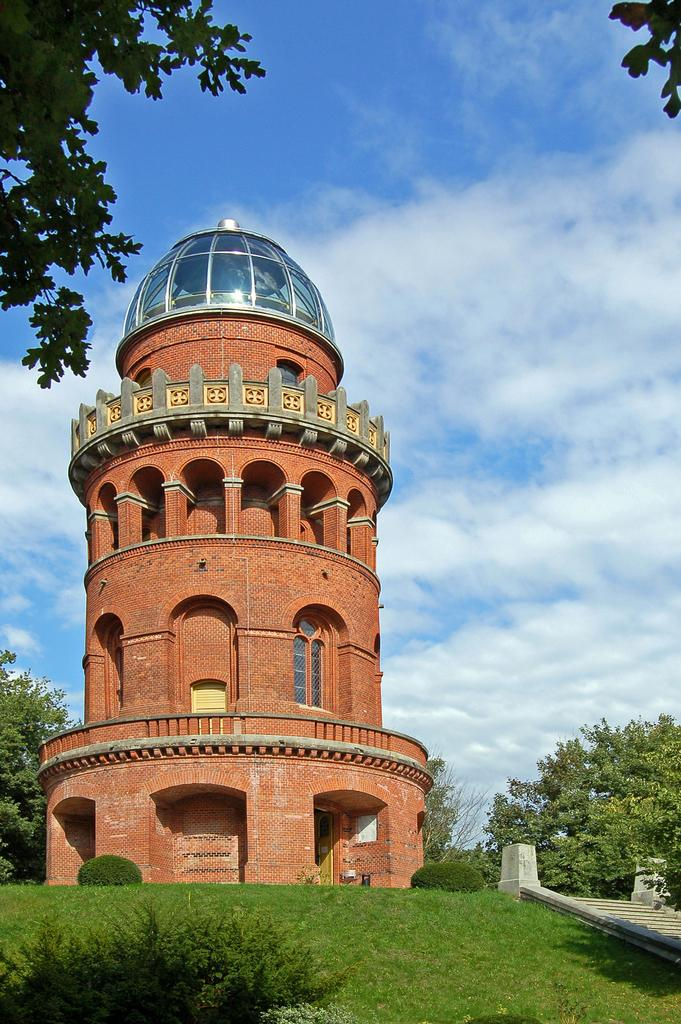What type of structure is in the image? There is a fort in the image. What can be seen on the ground in the image? Grass is present in the image. What type of vegetation is visible in the image? Plants and trees are in the image. What is the condition of the sky in the image? The sky is cloudy in the image. How many kittens are playing with the star cases in the image? There are no kittens present in the image, and therefore no such activity can be observed. What type of government is depicted in the image? There is no depiction of a government in the image; it features a fort, star cases, grass, plants, trees, and a cloudy sky. 